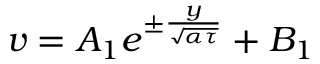<formula> <loc_0><loc_0><loc_500><loc_500>v = A _ { 1 } e ^ { \pm \frac { y } { \sqrt { \alpha \tau } } } + B _ { 1 }</formula> 